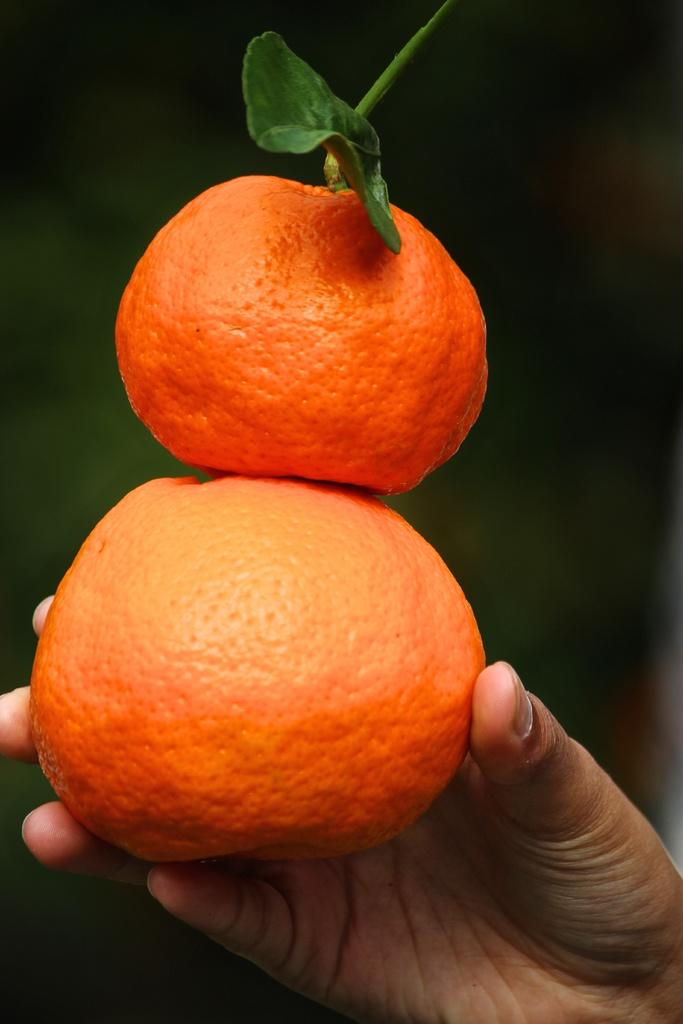Who or what is the main subject in the image? There is a person in the image. What is the person holding in their hand? The person is holding two oranges in their hand. What thrilling activity is the person performing in the image? There is no thrilling activity being performed in the image; the person is simply holding two oranges in their hand. 